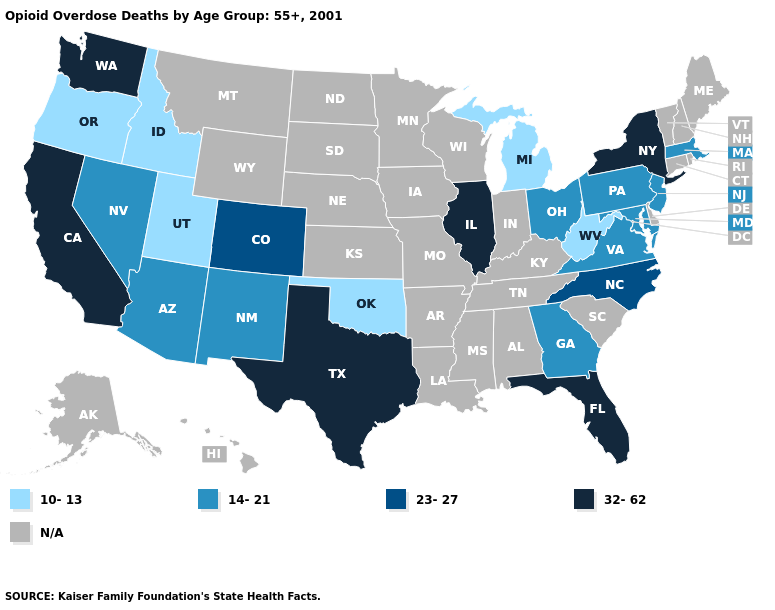Which states have the highest value in the USA?
Concise answer only. California, Florida, Illinois, New York, Texas, Washington. What is the highest value in states that border Idaho?
Be succinct. 32-62. What is the highest value in the South ?
Be succinct. 32-62. Does Oregon have the lowest value in the USA?
Quick response, please. Yes. What is the highest value in the West ?
Quick response, please. 32-62. Name the states that have a value in the range 23-27?
Answer briefly. Colorado, North Carolina. Name the states that have a value in the range N/A?
Keep it brief. Alabama, Alaska, Arkansas, Connecticut, Delaware, Hawaii, Indiana, Iowa, Kansas, Kentucky, Louisiana, Maine, Minnesota, Mississippi, Missouri, Montana, Nebraska, New Hampshire, North Dakota, Rhode Island, South Carolina, South Dakota, Tennessee, Vermont, Wisconsin, Wyoming. Is the legend a continuous bar?
Give a very brief answer. No. Name the states that have a value in the range 10-13?
Keep it brief. Idaho, Michigan, Oklahoma, Oregon, Utah, West Virginia. What is the value of Maryland?
Be succinct. 14-21. 